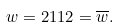Convert formula to latex. <formula><loc_0><loc_0><loc_500><loc_500>w = 2 1 1 2 = \overline { w } .</formula> 